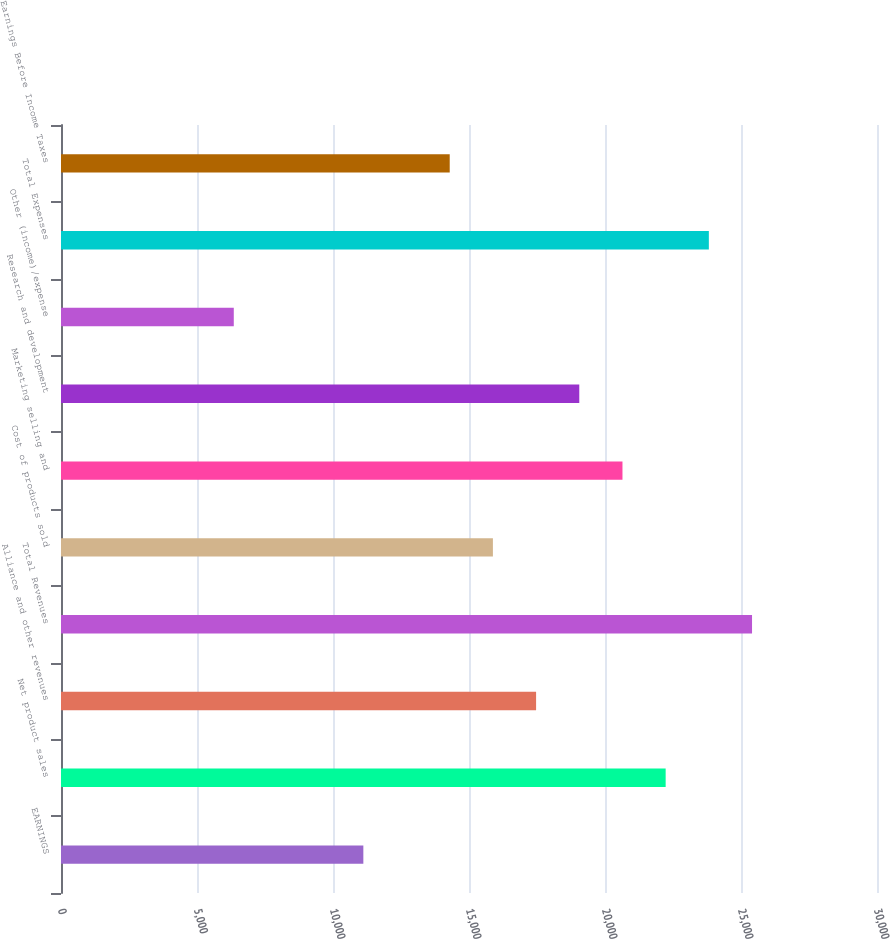Convert chart. <chart><loc_0><loc_0><loc_500><loc_500><bar_chart><fcel>EARNINGS<fcel>Net product sales<fcel>Alliance and other revenues<fcel>Total Revenues<fcel>Cost of products sold<fcel>Marketing selling and<fcel>Research and development<fcel>Other (income)/expense<fcel>Total Expenses<fcel>Earnings Before Income Taxes<nl><fcel>11115.7<fcel>22230.1<fcel>17466.8<fcel>25405.7<fcel>15879<fcel>20642.3<fcel>19054.6<fcel>6352.32<fcel>23817.9<fcel>14291.2<nl></chart> 